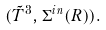Convert formula to latex. <formula><loc_0><loc_0><loc_500><loc_500>( \tilde { T } ^ { 3 } , \Sigma ^ { i n } ( R ) ) .</formula> 